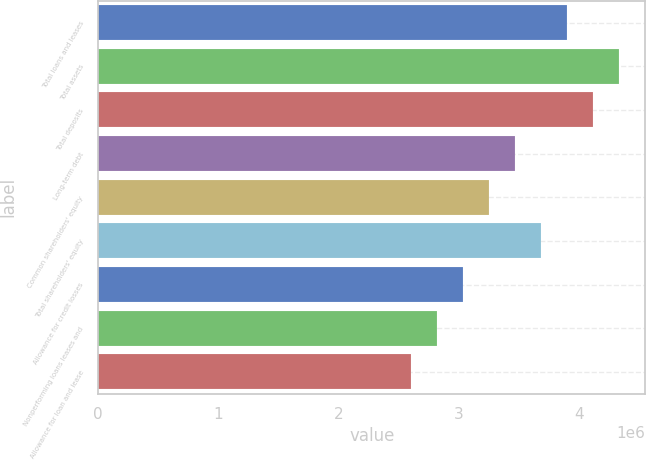Convert chart. <chart><loc_0><loc_0><loc_500><loc_500><bar_chart><fcel>Total loans and leases<fcel>Total assets<fcel>Total deposits<fcel>Long-term debt<fcel>Common shareholders' equity<fcel>Total shareholders' equity<fcel>Allowance for credit losses<fcel>Nonperforming loans leases and<fcel>Allowance for loan and lease<nl><fcel>3.90407e+06<fcel>4.33786e+06<fcel>4.12097e+06<fcel>3.47029e+06<fcel>3.25339e+06<fcel>3.68718e+06<fcel>3.0365e+06<fcel>2.81961e+06<fcel>2.60272e+06<nl></chart> 